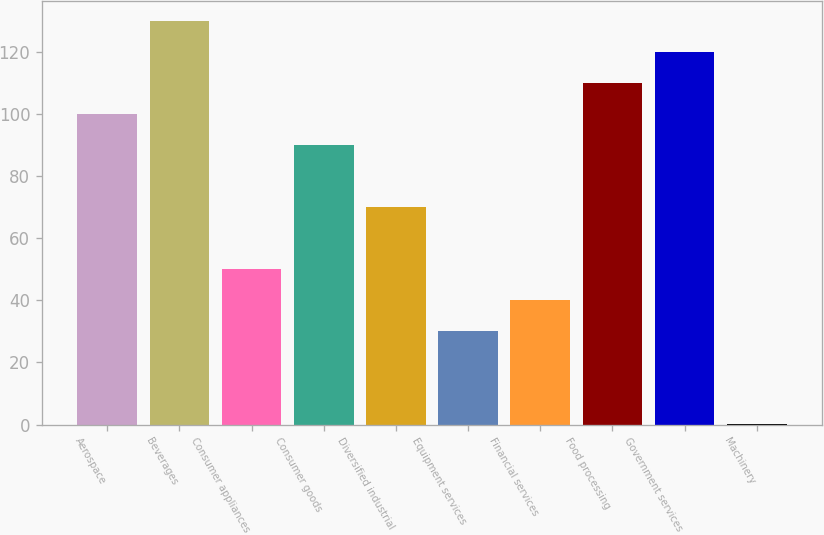Convert chart. <chart><loc_0><loc_0><loc_500><loc_500><bar_chart><fcel>Aerospace<fcel>Beverages<fcel>Consumer appliances<fcel>Consumer goods<fcel>Diversified industrial<fcel>Equipment services<fcel>Financial services<fcel>Food processing<fcel>Government services<fcel>Machinery<nl><fcel>100<fcel>129.97<fcel>50.05<fcel>90.01<fcel>70.03<fcel>30.07<fcel>40.06<fcel>109.99<fcel>119.98<fcel>0.1<nl></chart> 